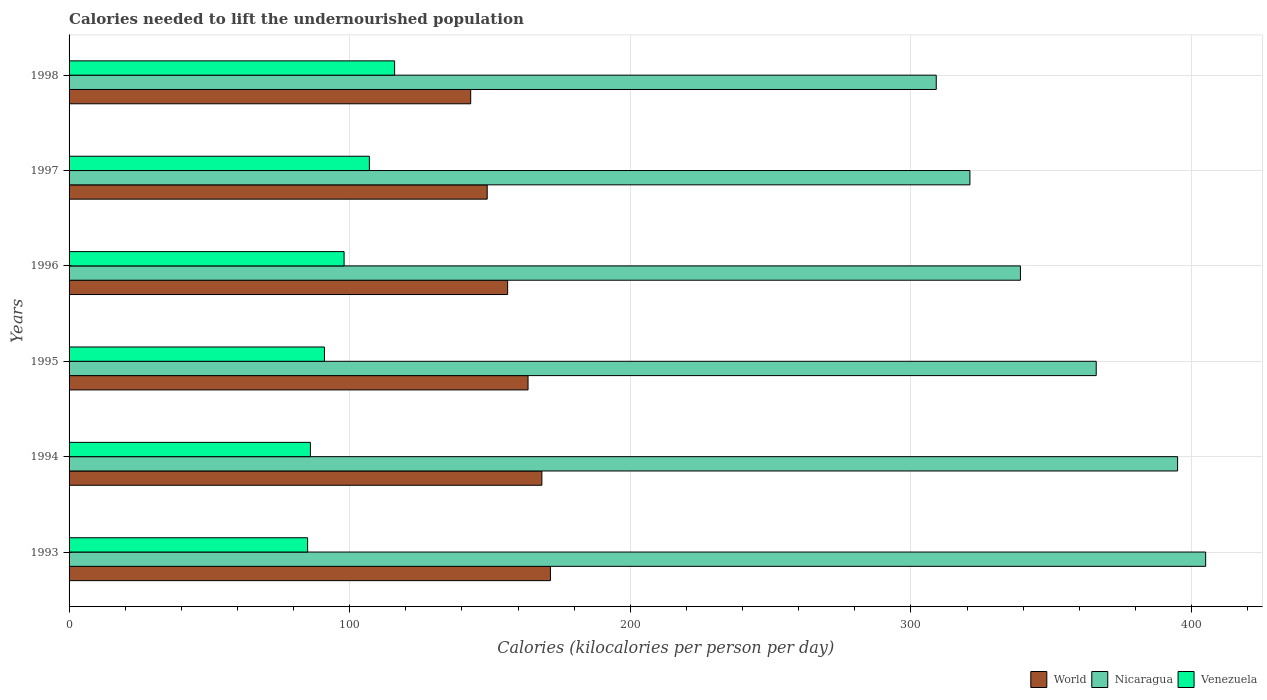How many different coloured bars are there?
Make the answer very short. 3. How many groups of bars are there?
Offer a very short reply. 6. How many bars are there on the 5th tick from the top?
Keep it short and to the point. 3. What is the label of the 4th group of bars from the top?
Keep it short and to the point. 1995. In how many cases, is the number of bars for a given year not equal to the number of legend labels?
Make the answer very short. 0. What is the total calories needed to lift the undernourished population in Nicaragua in 1994?
Provide a succinct answer. 395. Across all years, what is the maximum total calories needed to lift the undernourished population in World?
Provide a short and direct response. 171.52. Across all years, what is the minimum total calories needed to lift the undernourished population in Nicaragua?
Your response must be concise. 309. In which year was the total calories needed to lift the undernourished population in Nicaragua minimum?
Make the answer very short. 1998. What is the total total calories needed to lift the undernourished population in World in the graph?
Offer a terse response. 951.92. What is the difference between the total calories needed to lift the undernourished population in World in 1994 and that in 1997?
Make the answer very short. 19.48. What is the difference between the total calories needed to lift the undernourished population in World in 1994 and the total calories needed to lift the undernourished population in Venezuela in 1993?
Your response must be concise. 83.47. What is the average total calories needed to lift the undernourished population in Nicaragua per year?
Make the answer very short. 355.83. In the year 1997, what is the difference between the total calories needed to lift the undernourished population in World and total calories needed to lift the undernourished population in Nicaragua?
Your response must be concise. -172.01. In how many years, is the total calories needed to lift the undernourished population in World greater than 120 kilocalories?
Offer a very short reply. 6. What is the ratio of the total calories needed to lift the undernourished population in Venezuela in 1993 to that in 1997?
Offer a terse response. 0.79. Is the difference between the total calories needed to lift the undernourished population in World in 1993 and 1996 greater than the difference between the total calories needed to lift the undernourished population in Nicaragua in 1993 and 1996?
Offer a terse response. No. What is the difference between the highest and the second highest total calories needed to lift the undernourished population in Venezuela?
Keep it short and to the point. 9. What is the difference between the highest and the lowest total calories needed to lift the undernourished population in Venezuela?
Your response must be concise. 31. In how many years, is the total calories needed to lift the undernourished population in Nicaragua greater than the average total calories needed to lift the undernourished population in Nicaragua taken over all years?
Your answer should be compact. 3. Is the sum of the total calories needed to lift the undernourished population in Nicaragua in 1994 and 1995 greater than the maximum total calories needed to lift the undernourished population in World across all years?
Your response must be concise. Yes. What does the 3rd bar from the top in 1995 represents?
Give a very brief answer. World. What does the 2nd bar from the bottom in 1997 represents?
Offer a terse response. Nicaragua. Is it the case that in every year, the sum of the total calories needed to lift the undernourished population in World and total calories needed to lift the undernourished population in Venezuela is greater than the total calories needed to lift the undernourished population in Nicaragua?
Offer a terse response. No. How many bars are there?
Give a very brief answer. 18. How many years are there in the graph?
Your answer should be very brief. 6. What is the difference between two consecutive major ticks on the X-axis?
Give a very brief answer. 100. Does the graph contain any zero values?
Provide a short and direct response. No. How many legend labels are there?
Provide a short and direct response. 3. How are the legend labels stacked?
Keep it short and to the point. Horizontal. What is the title of the graph?
Offer a very short reply. Calories needed to lift the undernourished population. Does "Cote d'Ivoire" appear as one of the legend labels in the graph?
Offer a terse response. No. What is the label or title of the X-axis?
Keep it short and to the point. Calories (kilocalories per person per day). What is the Calories (kilocalories per person per day) of World in 1993?
Keep it short and to the point. 171.52. What is the Calories (kilocalories per person per day) in Nicaragua in 1993?
Provide a succinct answer. 405. What is the Calories (kilocalories per person per day) of World in 1994?
Make the answer very short. 168.47. What is the Calories (kilocalories per person per day) of Nicaragua in 1994?
Make the answer very short. 395. What is the Calories (kilocalories per person per day) in Venezuela in 1994?
Make the answer very short. 86. What is the Calories (kilocalories per person per day) of World in 1995?
Offer a very short reply. 163.55. What is the Calories (kilocalories per person per day) in Nicaragua in 1995?
Your answer should be compact. 366. What is the Calories (kilocalories per person per day) in Venezuela in 1995?
Your answer should be compact. 91. What is the Calories (kilocalories per person per day) in World in 1996?
Make the answer very short. 156.27. What is the Calories (kilocalories per person per day) in Nicaragua in 1996?
Your response must be concise. 339. What is the Calories (kilocalories per person per day) of World in 1997?
Provide a short and direct response. 148.99. What is the Calories (kilocalories per person per day) of Nicaragua in 1997?
Give a very brief answer. 321. What is the Calories (kilocalories per person per day) in Venezuela in 1997?
Your answer should be compact. 107. What is the Calories (kilocalories per person per day) of World in 1998?
Provide a succinct answer. 143.11. What is the Calories (kilocalories per person per day) in Nicaragua in 1998?
Provide a succinct answer. 309. What is the Calories (kilocalories per person per day) of Venezuela in 1998?
Provide a short and direct response. 116. Across all years, what is the maximum Calories (kilocalories per person per day) of World?
Your response must be concise. 171.52. Across all years, what is the maximum Calories (kilocalories per person per day) of Nicaragua?
Your answer should be compact. 405. Across all years, what is the maximum Calories (kilocalories per person per day) of Venezuela?
Offer a terse response. 116. Across all years, what is the minimum Calories (kilocalories per person per day) in World?
Provide a succinct answer. 143.11. Across all years, what is the minimum Calories (kilocalories per person per day) of Nicaragua?
Give a very brief answer. 309. Across all years, what is the minimum Calories (kilocalories per person per day) in Venezuela?
Your response must be concise. 85. What is the total Calories (kilocalories per person per day) in World in the graph?
Offer a very short reply. 951.92. What is the total Calories (kilocalories per person per day) in Nicaragua in the graph?
Your response must be concise. 2135. What is the total Calories (kilocalories per person per day) of Venezuela in the graph?
Your answer should be very brief. 583. What is the difference between the Calories (kilocalories per person per day) in World in 1993 and that in 1994?
Ensure brevity in your answer.  3.05. What is the difference between the Calories (kilocalories per person per day) of Nicaragua in 1993 and that in 1994?
Provide a succinct answer. 10. What is the difference between the Calories (kilocalories per person per day) in Venezuela in 1993 and that in 1994?
Make the answer very short. -1. What is the difference between the Calories (kilocalories per person per day) of World in 1993 and that in 1995?
Your answer should be compact. 7.97. What is the difference between the Calories (kilocalories per person per day) in Nicaragua in 1993 and that in 1995?
Your response must be concise. 39. What is the difference between the Calories (kilocalories per person per day) of Venezuela in 1993 and that in 1995?
Your answer should be compact. -6. What is the difference between the Calories (kilocalories per person per day) in World in 1993 and that in 1996?
Offer a terse response. 15.25. What is the difference between the Calories (kilocalories per person per day) of Nicaragua in 1993 and that in 1996?
Provide a succinct answer. 66. What is the difference between the Calories (kilocalories per person per day) in Venezuela in 1993 and that in 1996?
Give a very brief answer. -13. What is the difference between the Calories (kilocalories per person per day) in World in 1993 and that in 1997?
Your answer should be very brief. 22.53. What is the difference between the Calories (kilocalories per person per day) in Nicaragua in 1993 and that in 1997?
Offer a very short reply. 84. What is the difference between the Calories (kilocalories per person per day) of World in 1993 and that in 1998?
Give a very brief answer. 28.41. What is the difference between the Calories (kilocalories per person per day) of Nicaragua in 1993 and that in 1998?
Offer a terse response. 96. What is the difference between the Calories (kilocalories per person per day) in Venezuela in 1993 and that in 1998?
Provide a succinct answer. -31. What is the difference between the Calories (kilocalories per person per day) in World in 1994 and that in 1995?
Ensure brevity in your answer.  4.93. What is the difference between the Calories (kilocalories per person per day) of Nicaragua in 1994 and that in 1995?
Keep it short and to the point. 29. What is the difference between the Calories (kilocalories per person per day) in World in 1994 and that in 1996?
Your answer should be very brief. 12.2. What is the difference between the Calories (kilocalories per person per day) of World in 1994 and that in 1997?
Your response must be concise. 19.48. What is the difference between the Calories (kilocalories per person per day) in World in 1994 and that in 1998?
Your response must be concise. 25.36. What is the difference between the Calories (kilocalories per person per day) of Venezuela in 1994 and that in 1998?
Provide a short and direct response. -30. What is the difference between the Calories (kilocalories per person per day) in World in 1995 and that in 1996?
Make the answer very short. 7.27. What is the difference between the Calories (kilocalories per person per day) of Venezuela in 1995 and that in 1996?
Ensure brevity in your answer.  -7. What is the difference between the Calories (kilocalories per person per day) of World in 1995 and that in 1997?
Your answer should be compact. 14.55. What is the difference between the Calories (kilocalories per person per day) in Nicaragua in 1995 and that in 1997?
Provide a short and direct response. 45. What is the difference between the Calories (kilocalories per person per day) in World in 1995 and that in 1998?
Ensure brevity in your answer.  20.44. What is the difference between the Calories (kilocalories per person per day) in World in 1996 and that in 1997?
Provide a short and direct response. 7.28. What is the difference between the Calories (kilocalories per person per day) of Venezuela in 1996 and that in 1997?
Give a very brief answer. -9. What is the difference between the Calories (kilocalories per person per day) of World in 1996 and that in 1998?
Your answer should be very brief. 13.16. What is the difference between the Calories (kilocalories per person per day) in World in 1997 and that in 1998?
Provide a short and direct response. 5.89. What is the difference between the Calories (kilocalories per person per day) in World in 1993 and the Calories (kilocalories per person per day) in Nicaragua in 1994?
Offer a terse response. -223.48. What is the difference between the Calories (kilocalories per person per day) in World in 1993 and the Calories (kilocalories per person per day) in Venezuela in 1994?
Provide a succinct answer. 85.52. What is the difference between the Calories (kilocalories per person per day) in Nicaragua in 1993 and the Calories (kilocalories per person per day) in Venezuela in 1994?
Your answer should be very brief. 319. What is the difference between the Calories (kilocalories per person per day) in World in 1993 and the Calories (kilocalories per person per day) in Nicaragua in 1995?
Provide a succinct answer. -194.48. What is the difference between the Calories (kilocalories per person per day) of World in 1993 and the Calories (kilocalories per person per day) of Venezuela in 1995?
Your answer should be very brief. 80.52. What is the difference between the Calories (kilocalories per person per day) in Nicaragua in 1993 and the Calories (kilocalories per person per day) in Venezuela in 1995?
Your answer should be very brief. 314. What is the difference between the Calories (kilocalories per person per day) in World in 1993 and the Calories (kilocalories per person per day) in Nicaragua in 1996?
Keep it short and to the point. -167.48. What is the difference between the Calories (kilocalories per person per day) of World in 1993 and the Calories (kilocalories per person per day) of Venezuela in 1996?
Provide a short and direct response. 73.52. What is the difference between the Calories (kilocalories per person per day) of Nicaragua in 1993 and the Calories (kilocalories per person per day) of Venezuela in 1996?
Provide a short and direct response. 307. What is the difference between the Calories (kilocalories per person per day) in World in 1993 and the Calories (kilocalories per person per day) in Nicaragua in 1997?
Keep it short and to the point. -149.48. What is the difference between the Calories (kilocalories per person per day) of World in 1993 and the Calories (kilocalories per person per day) of Venezuela in 1997?
Keep it short and to the point. 64.52. What is the difference between the Calories (kilocalories per person per day) in Nicaragua in 1993 and the Calories (kilocalories per person per day) in Venezuela in 1997?
Your response must be concise. 298. What is the difference between the Calories (kilocalories per person per day) of World in 1993 and the Calories (kilocalories per person per day) of Nicaragua in 1998?
Provide a short and direct response. -137.48. What is the difference between the Calories (kilocalories per person per day) in World in 1993 and the Calories (kilocalories per person per day) in Venezuela in 1998?
Keep it short and to the point. 55.52. What is the difference between the Calories (kilocalories per person per day) of Nicaragua in 1993 and the Calories (kilocalories per person per day) of Venezuela in 1998?
Provide a succinct answer. 289. What is the difference between the Calories (kilocalories per person per day) in World in 1994 and the Calories (kilocalories per person per day) in Nicaragua in 1995?
Make the answer very short. -197.53. What is the difference between the Calories (kilocalories per person per day) of World in 1994 and the Calories (kilocalories per person per day) of Venezuela in 1995?
Provide a succinct answer. 77.47. What is the difference between the Calories (kilocalories per person per day) of Nicaragua in 1994 and the Calories (kilocalories per person per day) of Venezuela in 1995?
Provide a short and direct response. 304. What is the difference between the Calories (kilocalories per person per day) of World in 1994 and the Calories (kilocalories per person per day) of Nicaragua in 1996?
Your answer should be very brief. -170.53. What is the difference between the Calories (kilocalories per person per day) in World in 1994 and the Calories (kilocalories per person per day) in Venezuela in 1996?
Keep it short and to the point. 70.47. What is the difference between the Calories (kilocalories per person per day) of Nicaragua in 1994 and the Calories (kilocalories per person per day) of Venezuela in 1996?
Provide a succinct answer. 297. What is the difference between the Calories (kilocalories per person per day) of World in 1994 and the Calories (kilocalories per person per day) of Nicaragua in 1997?
Keep it short and to the point. -152.53. What is the difference between the Calories (kilocalories per person per day) of World in 1994 and the Calories (kilocalories per person per day) of Venezuela in 1997?
Ensure brevity in your answer.  61.47. What is the difference between the Calories (kilocalories per person per day) in Nicaragua in 1994 and the Calories (kilocalories per person per day) in Venezuela in 1997?
Offer a very short reply. 288. What is the difference between the Calories (kilocalories per person per day) in World in 1994 and the Calories (kilocalories per person per day) in Nicaragua in 1998?
Provide a succinct answer. -140.53. What is the difference between the Calories (kilocalories per person per day) in World in 1994 and the Calories (kilocalories per person per day) in Venezuela in 1998?
Your response must be concise. 52.47. What is the difference between the Calories (kilocalories per person per day) in Nicaragua in 1994 and the Calories (kilocalories per person per day) in Venezuela in 1998?
Your answer should be compact. 279. What is the difference between the Calories (kilocalories per person per day) of World in 1995 and the Calories (kilocalories per person per day) of Nicaragua in 1996?
Your answer should be very brief. -175.45. What is the difference between the Calories (kilocalories per person per day) of World in 1995 and the Calories (kilocalories per person per day) of Venezuela in 1996?
Offer a very short reply. 65.55. What is the difference between the Calories (kilocalories per person per day) in Nicaragua in 1995 and the Calories (kilocalories per person per day) in Venezuela in 1996?
Offer a terse response. 268. What is the difference between the Calories (kilocalories per person per day) of World in 1995 and the Calories (kilocalories per person per day) of Nicaragua in 1997?
Provide a short and direct response. -157.45. What is the difference between the Calories (kilocalories per person per day) of World in 1995 and the Calories (kilocalories per person per day) of Venezuela in 1997?
Provide a succinct answer. 56.55. What is the difference between the Calories (kilocalories per person per day) in Nicaragua in 1995 and the Calories (kilocalories per person per day) in Venezuela in 1997?
Keep it short and to the point. 259. What is the difference between the Calories (kilocalories per person per day) of World in 1995 and the Calories (kilocalories per person per day) of Nicaragua in 1998?
Offer a terse response. -145.45. What is the difference between the Calories (kilocalories per person per day) in World in 1995 and the Calories (kilocalories per person per day) in Venezuela in 1998?
Offer a terse response. 47.55. What is the difference between the Calories (kilocalories per person per day) in Nicaragua in 1995 and the Calories (kilocalories per person per day) in Venezuela in 1998?
Offer a very short reply. 250. What is the difference between the Calories (kilocalories per person per day) in World in 1996 and the Calories (kilocalories per person per day) in Nicaragua in 1997?
Give a very brief answer. -164.73. What is the difference between the Calories (kilocalories per person per day) in World in 1996 and the Calories (kilocalories per person per day) in Venezuela in 1997?
Keep it short and to the point. 49.27. What is the difference between the Calories (kilocalories per person per day) of Nicaragua in 1996 and the Calories (kilocalories per person per day) of Venezuela in 1997?
Keep it short and to the point. 232. What is the difference between the Calories (kilocalories per person per day) in World in 1996 and the Calories (kilocalories per person per day) in Nicaragua in 1998?
Offer a very short reply. -152.73. What is the difference between the Calories (kilocalories per person per day) in World in 1996 and the Calories (kilocalories per person per day) in Venezuela in 1998?
Your response must be concise. 40.27. What is the difference between the Calories (kilocalories per person per day) of Nicaragua in 1996 and the Calories (kilocalories per person per day) of Venezuela in 1998?
Keep it short and to the point. 223. What is the difference between the Calories (kilocalories per person per day) in World in 1997 and the Calories (kilocalories per person per day) in Nicaragua in 1998?
Ensure brevity in your answer.  -160.01. What is the difference between the Calories (kilocalories per person per day) in World in 1997 and the Calories (kilocalories per person per day) in Venezuela in 1998?
Your answer should be very brief. 32.99. What is the difference between the Calories (kilocalories per person per day) in Nicaragua in 1997 and the Calories (kilocalories per person per day) in Venezuela in 1998?
Provide a succinct answer. 205. What is the average Calories (kilocalories per person per day) in World per year?
Keep it short and to the point. 158.65. What is the average Calories (kilocalories per person per day) of Nicaragua per year?
Ensure brevity in your answer.  355.83. What is the average Calories (kilocalories per person per day) of Venezuela per year?
Offer a terse response. 97.17. In the year 1993, what is the difference between the Calories (kilocalories per person per day) in World and Calories (kilocalories per person per day) in Nicaragua?
Your answer should be very brief. -233.48. In the year 1993, what is the difference between the Calories (kilocalories per person per day) in World and Calories (kilocalories per person per day) in Venezuela?
Offer a terse response. 86.52. In the year 1993, what is the difference between the Calories (kilocalories per person per day) in Nicaragua and Calories (kilocalories per person per day) in Venezuela?
Your response must be concise. 320. In the year 1994, what is the difference between the Calories (kilocalories per person per day) in World and Calories (kilocalories per person per day) in Nicaragua?
Make the answer very short. -226.53. In the year 1994, what is the difference between the Calories (kilocalories per person per day) in World and Calories (kilocalories per person per day) in Venezuela?
Your answer should be very brief. 82.47. In the year 1994, what is the difference between the Calories (kilocalories per person per day) in Nicaragua and Calories (kilocalories per person per day) in Venezuela?
Ensure brevity in your answer.  309. In the year 1995, what is the difference between the Calories (kilocalories per person per day) of World and Calories (kilocalories per person per day) of Nicaragua?
Your answer should be compact. -202.45. In the year 1995, what is the difference between the Calories (kilocalories per person per day) of World and Calories (kilocalories per person per day) of Venezuela?
Your answer should be very brief. 72.55. In the year 1995, what is the difference between the Calories (kilocalories per person per day) of Nicaragua and Calories (kilocalories per person per day) of Venezuela?
Provide a succinct answer. 275. In the year 1996, what is the difference between the Calories (kilocalories per person per day) in World and Calories (kilocalories per person per day) in Nicaragua?
Offer a terse response. -182.73. In the year 1996, what is the difference between the Calories (kilocalories per person per day) of World and Calories (kilocalories per person per day) of Venezuela?
Provide a succinct answer. 58.27. In the year 1996, what is the difference between the Calories (kilocalories per person per day) in Nicaragua and Calories (kilocalories per person per day) in Venezuela?
Provide a short and direct response. 241. In the year 1997, what is the difference between the Calories (kilocalories per person per day) of World and Calories (kilocalories per person per day) of Nicaragua?
Keep it short and to the point. -172.01. In the year 1997, what is the difference between the Calories (kilocalories per person per day) in World and Calories (kilocalories per person per day) in Venezuela?
Make the answer very short. 41.99. In the year 1997, what is the difference between the Calories (kilocalories per person per day) in Nicaragua and Calories (kilocalories per person per day) in Venezuela?
Make the answer very short. 214. In the year 1998, what is the difference between the Calories (kilocalories per person per day) in World and Calories (kilocalories per person per day) in Nicaragua?
Your answer should be compact. -165.89. In the year 1998, what is the difference between the Calories (kilocalories per person per day) in World and Calories (kilocalories per person per day) in Venezuela?
Make the answer very short. 27.11. In the year 1998, what is the difference between the Calories (kilocalories per person per day) of Nicaragua and Calories (kilocalories per person per day) of Venezuela?
Give a very brief answer. 193. What is the ratio of the Calories (kilocalories per person per day) of World in 1993 to that in 1994?
Your answer should be compact. 1.02. What is the ratio of the Calories (kilocalories per person per day) in Nicaragua in 1993 to that in 1994?
Your response must be concise. 1.03. What is the ratio of the Calories (kilocalories per person per day) in Venezuela in 1993 to that in 1994?
Make the answer very short. 0.99. What is the ratio of the Calories (kilocalories per person per day) in World in 1993 to that in 1995?
Make the answer very short. 1.05. What is the ratio of the Calories (kilocalories per person per day) in Nicaragua in 1993 to that in 1995?
Make the answer very short. 1.11. What is the ratio of the Calories (kilocalories per person per day) in Venezuela in 1993 to that in 1995?
Your response must be concise. 0.93. What is the ratio of the Calories (kilocalories per person per day) of World in 1993 to that in 1996?
Give a very brief answer. 1.1. What is the ratio of the Calories (kilocalories per person per day) in Nicaragua in 1993 to that in 1996?
Offer a terse response. 1.19. What is the ratio of the Calories (kilocalories per person per day) of Venezuela in 1993 to that in 1996?
Offer a terse response. 0.87. What is the ratio of the Calories (kilocalories per person per day) in World in 1993 to that in 1997?
Make the answer very short. 1.15. What is the ratio of the Calories (kilocalories per person per day) of Nicaragua in 1993 to that in 1997?
Offer a terse response. 1.26. What is the ratio of the Calories (kilocalories per person per day) in Venezuela in 1993 to that in 1997?
Your answer should be compact. 0.79. What is the ratio of the Calories (kilocalories per person per day) of World in 1993 to that in 1998?
Offer a very short reply. 1.2. What is the ratio of the Calories (kilocalories per person per day) of Nicaragua in 1993 to that in 1998?
Your response must be concise. 1.31. What is the ratio of the Calories (kilocalories per person per day) in Venezuela in 1993 to that in 1998?
Your answer should be compact. 0.73. What is the ratio of the Calories (kilocalories per person per day) of World in 1994 to that in 1995?
Your response must be concise. 1.03. What is the ratio of the Calories (kilocalories per person per day) in Nicaragua in 1994 to that in 1995?
Make the answer very short. 1.08. What is the ratio of the Calories (kilocalories per person per day) in Venezuela in 1994 to that in 1995?
Give a very brief answer. 0.95. What is the ratio of the Calories (kilocalories per person per day) in World in 1994 to that in 1996?
Ensure brevity in your answer.  1.08. What is the ratio of the Calories (kilocalories per person per day) in Nicaragua in 1994 to that in 1996?
Your answer should be very brief. 1.17. What is the ratio of the Calories (kilocalories per person per day) of Venezuela in 1994 to that in 1996?
Give a very brief answer. 0.88. What is the ratio of the Calories (kilocalories per person per day) of World in 1994 to that in 1997?
Your response must be concise. 1.13. What is the ratio of the Calories (kilocalories per person per day) in Nicaragua in 1994 to that in 1997?
Keep it short and to the point. 1.23. What is the ratio of the Calories (kilocalories per person per day) of Venezuela in 1994 to that in 1997?
Your answer should be compact. 0.8. What is the ratio of the Calories (kilocalories per person per day) of World in 1994 to that in 1998?
Your answer should be very brief. 1.18. What is the ratio of the Calories (kilocalories per person per day) in Nicaragua in 1994 to that in 1998?
Offer a terse response. 1.28. What is the ratio of the Calories (kilocalories per person per day) in Venezuela in 1994 to that in 1998?
Provide a succinct answer. 0.74. What is the ratio of the Calories (kilocalories per person per day) of World in 1995 to that in 1996?
Keep it short and to the point. 1.05. What is the ratio of the Calories (kilocalories per person per day) of Nicaragua in 1995 to that in 1996?
Your answer should be compact. 1.08. What is the ratio of the Calories (kilocalories per person per day) in Venezuela in 1995 to that in 1996?
Offer a terse response. 0.93. What is the ratio of the Calories (kilocalories per person per day) of World in 1995 to that in 1997?
Keep it short and to the point. 1.1. What is the ratio of the Calories (kilocalories per person per day) of Nicaragua in 1995 to that in 1997?
Offer a very short reply. 1.14. What is the ratio of the Calories (kilocalories per person per day) in Venezuela in 1995 to that in 1997?
Keep it short and to the point. 0.85. What is the ratio of the Calories (kilocalories per person per day) in World in 1995 to that in 1998?
Give a very brief answer. 1.14. What is the ratio of the Calories (kilocalories per person per day) of Nicaragua in 1995 to that in 1998?
Provide a short and direct response. 1.18. What is the ratio of the Calories (kilocalories per person per day) in Venezuela in 1995 to that in 1998?
Provide a succinct answer. 0.78. What is the ratio of the Calories (kilocalories per person per day) of World in 1996 to that in 1997?
Provide a short and direct response. 1.05. What is the ratio of the Calories (kilocalories per person per day) in Nicaragua in 1996 to that in 1997?
Your answer should be very brief. 1.06. What is the ratio of the Calories (kilocalories per person per day) of Venezuela in 1996 to that in 1997?
Your response must be concise. 0.92. What is the ratio of the Calories (kilocalories per person per day) in World in 1996 to that in 1998?
Ensure brevity in your answer.  1.09. What is the ratio of the Calories (kilocalories per person per day) in Nicaragua in 1996 to that in 1998?
Ensure brevity in your answer.  1.1. What is the ratio of the Calories (kilocalories per person per day) of Venezuela in 1996 to that in 1998?
Make the answer very short. 0.84. What is the ratio of the Calories (kilocalories per person per day) of World in 1997 to that in 1998?
Your answer should be very brief. 1.04. What is the ratio of the Calories (kilocalories per person per day) of Nicaragua in 1997 to that in 1998?
Ensure brevity in your answer.  1.04. What is the ratio of the Calories (kilocalories per person per day) of Venezuela in 1997 to that in 1998?
Your answer should be very brief. 0.92. What is the difference between the highest and the second highest Calories (kilocalories per person per day) of World?
Your answer should be compact. 3.05. What is the difference between the highest and the second highest Calories (kilocalories per person per day) of Nicaragua?
Ensure brevity in your answer.  10. What is the difference between the highest and the second highest Calories (kilocalories per person per day) in Venezuela?
Ensure brevity in your answer.  9. What is the difference between the highest and the lowest Calories (kilocalories per person per day) in World?
Ensure brevity in your answer.  28.41. What is the difference between the highest and the lowest Calories (kilocalories per person per day) of Nicaragua?
Offer a terse response. 96. What is the difference between the highest and the lowest Calories (kilocalories per person per day) in Venezuela?
Provide a succinct answer. 31. 